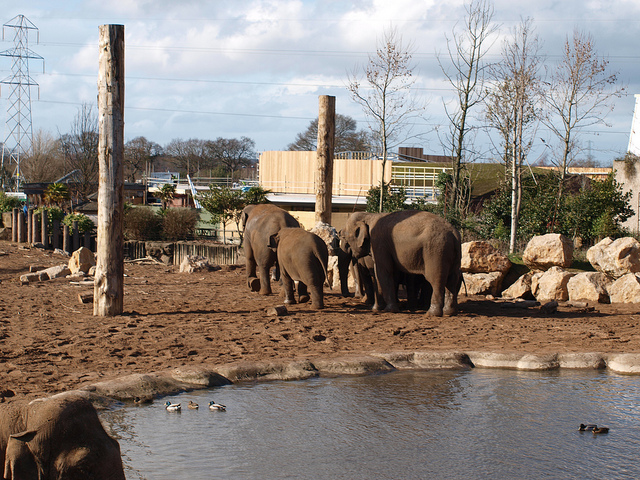<image>How many elephants are standing near the wall? I don't know exactly how many elephants are standing near the wall. It can be 3 or 4. How many elephants are standing near the wall? I don't know how many elephants are standing near the wall. It can be either 3 or 4. 